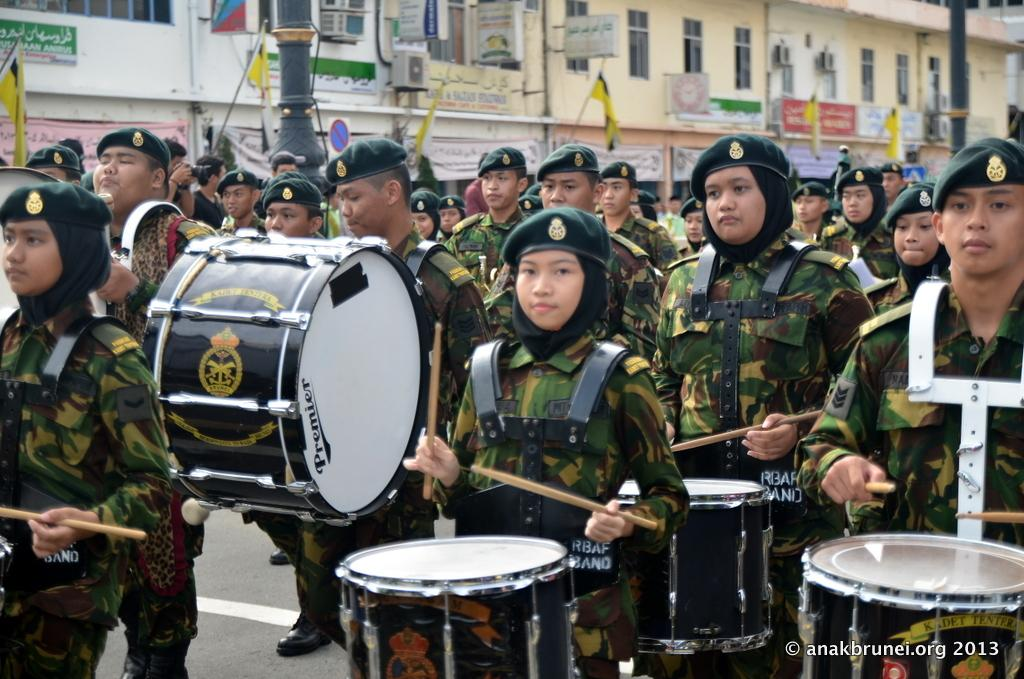Who is present in the image? There are people in the image. What are the people doing in the image? The people are standing on the road and playing drums. What are the people wearing in the image? The people are wearing uniforms. What can be seen in the background of the image? There is a building in the background of the image. What type of bread can be seen in the image? There is no bread present in the image. What wish do the people in the image have? There is no indication of a wish in the image; the people are playing drums. 